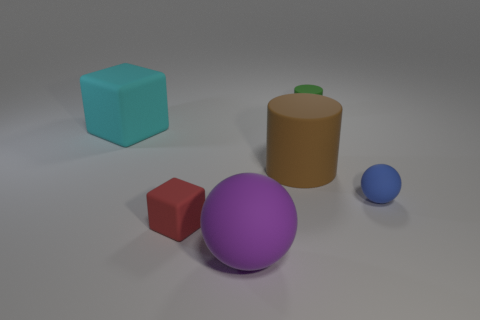Add 4 purple balls. How many objects exist? 10 Subtract all balls. How many objects are left? 4 Add 3 tiny matte objects. How many tiny matte objects exist? 6 Subtract 0 blue cylinders. How many objects are left? 6 Subtract all gray spheres. Subtract all blue cubes. How many spheres are left? 2 Subtract all green rubber cylinders. Subtract all tiny matte spheres. How many objects are left? 4 Add 4 big brown matte cylinders. How many big brown matte cylinders are left? 5 